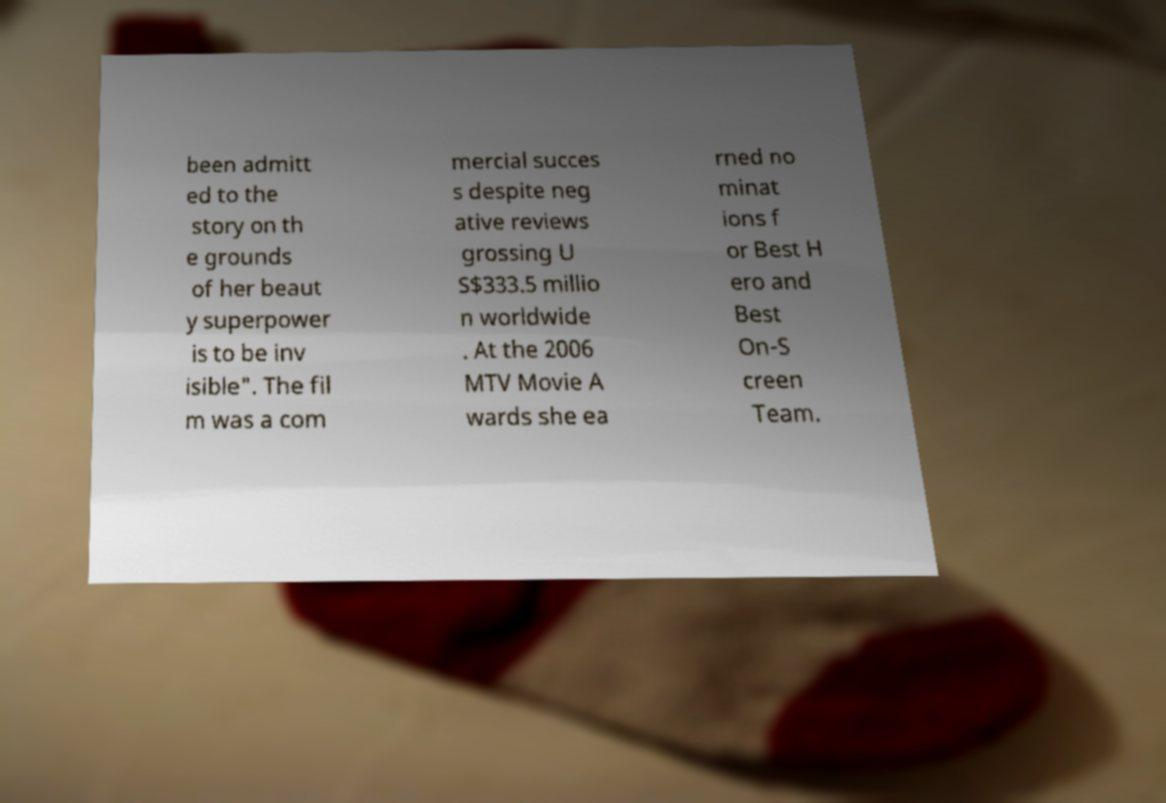Please identify and transcribe the text found in this image. been admitt ed to the story on th e grounds of her beaut y superpower is to be inv isible". The fil m was a com mercial succes s despite neg ative reviews grossing U S$333.5 millio n worldwide . At the 2006 MTV Movie A wards she ea rned no minat ions f or Best H ero and Best On-S creen Team. 